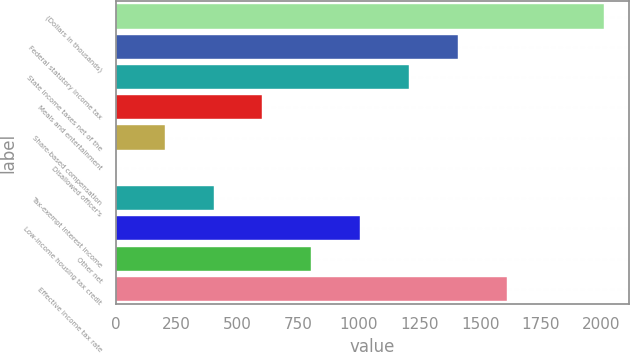Convert chart to OTSL. <chart><loc_0><loc_0><loc_500><loc_500><bar_chart><fcel>(Dollars in thousands)<fcel>Federal statutory income tax<fcel>State income taxes net of the<fcel>Meals and entertainment<fcel>Share-based compensation<fcel>Disallowed officer's<fcel>Tax-exempt interest income<fcel>Low-income housing tax credit<fcel>Other net<fcel>Effective income tax rate<nl><fcel>2012<fcel>1408.43<fcel>1207.24<fcel>603.67<fcel>201.29<fcel>0.1<fcel>402.48<fcel>1006.05<fcel>804.86<fcel>1609.62<nl></chart> 